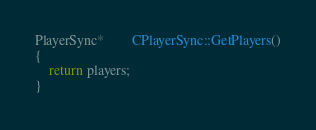Convert code to text. <code><loc_0><loc_0><loc_500><loc_500><_C++_>PlayerSync*		CPlayerSync::GetPlayers()
{
	return players;
}</code> 